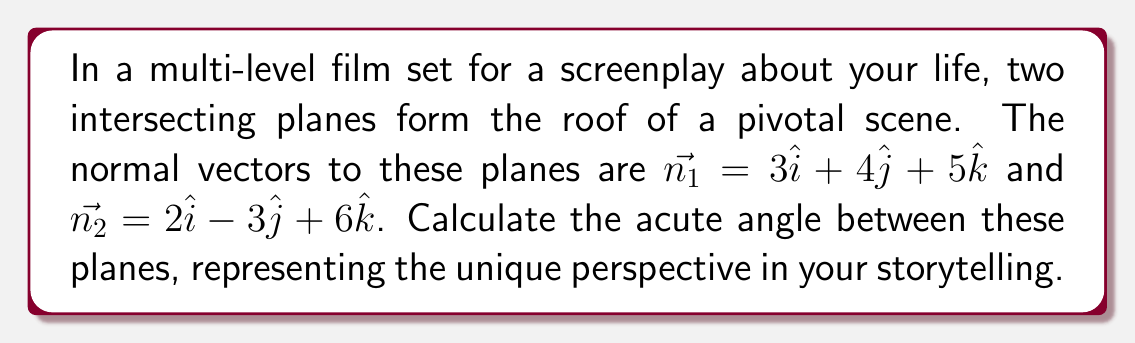Give your solution to this math problem. To find the angle between two intersecting planes, we can use the angle between their normal vectors. The steps are as follows:

1) The angle $\theta$ between two vectors $\vec{a}$ and $\vec{b}$ is given by:

   $$\cos \theta = \frac{\vec{a} \cdot \vec{b}}{|\vec{a}||\vec{b}|}$$

2) Calculate the dot product $\vec{n_1} \cdot \vec{n_2}$:
   $$(3)(2) + (4)(-3) + (5)(6) = 6 - 12 + 30 = 24$$

3) Calculate the magnitudes of the vectors:
   $$|\vec{n_1}| = \sqrt{3^2 + 4^2 + 5^2} = \sqrt{50}$$
   $$|\vec{n_2}| = \sqrt{2^2 + (-3)^2 + 6^2} = \sqrt{49} = 7$$

4) Substitute into the formula:
   $$\cos \theta = \frac{24}{\sqrt{50} \cdot 7}$$

5) Simplify:
   $$\cos \theta = \frac{24}{7\sqrt{50}} = \frac{24\sqrt{2}}{70}$$

6) Take the inverse cosine (arccos) of both sides:
   $$\theta = \arccos(\frac{24\sqrt{2}}{70})$$

7) Calculate the result (in degrees):
   $$\theta \approx 53.13^\circ$$
Answer: $53.13^\circ$ 